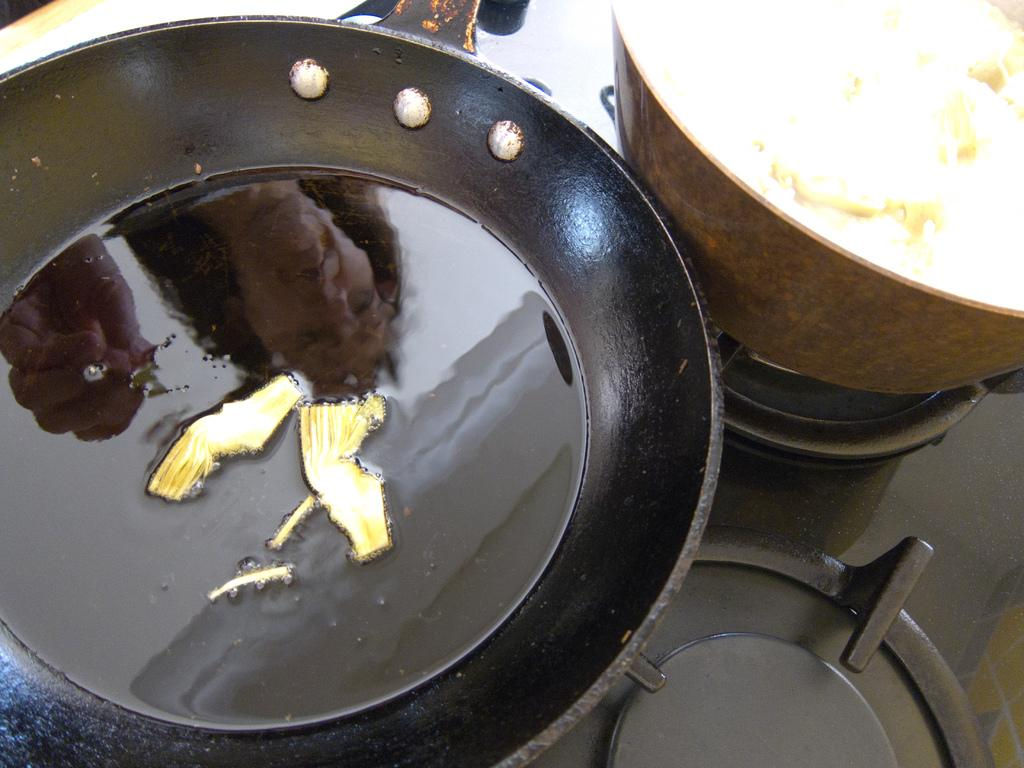What is in the pan that is visible in the image? There is a pan containing liquid and food in the image. What else can be seen in the image related to food preparation? There is a bowl containing food placed on the stove in the image. Can you see a fight between a toad and a donkey in the image? No, there is no fight between a toad and a donkey in the image. 